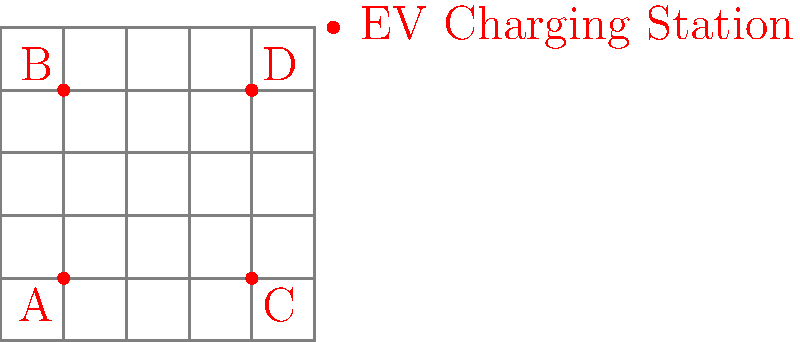In the given 5x5 city grid, four electric vehicle (EV) charging stations are placed at locations A(1,1), B(1,4), C(4,1), and D(4,4). What is the maximum Manhattan distance any point in the grid is from its nearest charging station? To solve this problem, we need to follow these steps:

1. Understand Manhattan distance: It's the sum of the absolute differences of the coordinates. For points $(x_1, y_1)$ and $(x_2, y_2)$, the Manhattan distance is $|x_1 - x_2| + |y_1 - y_2|$.

2. Identify the areas served by each charging station:
   - Station A serves the bottom-left quadrant
   - Station B serves the top-left quadrant
   - Station C serves the bottom-right quadrant
   - Station D serves the top-right quadrant

3. Find the point farthest from any station in each quadrant:
   - For A: (2,2) is farthest, with distance $|2-1| + |2-1| = 2$
   - For B: (2,5) is farthest, with distance $|2-1| + |5-4| = 2$
   - For C: (5,2) is farthest, with distance $|5-4| + |2-1| = 2$
   - For D: (5,5) is farthest, with distance $|5-4| + |5-4| = 2$

4. Identify the maximum distance:
   The maximum distance is 2 for all quadrants.

Therefore, the maximum Manhattan distance any point in the grid is from its nearest charging station is 2 units.
Answer: 2 units 